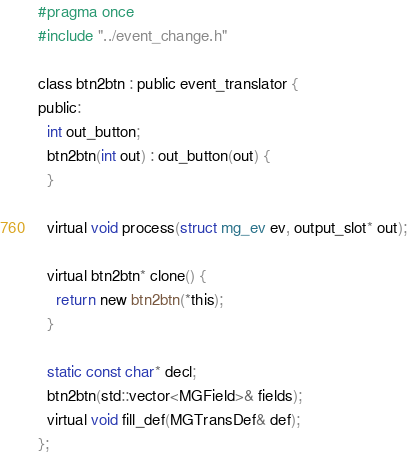Convert code to text. <code><loc_0><loc_0><loc_500><loc_500><_C_>#pragma once
#include "../event_change.h"

class btn2btn : public event_translator {
public:
  int out_button;
  btn2btn(int out) : out_button(out) {
  }

  virtual void process(struct mg_ev ev, output_slot* out);

  virtual btn2btn* clone() {
    return new btn2btn(*this);
  }

  static const char* decl;
  btn2btn(std::vector<MGField>& fields);
  virtual void fill_def(MGTransDef& def);
};
</code> 